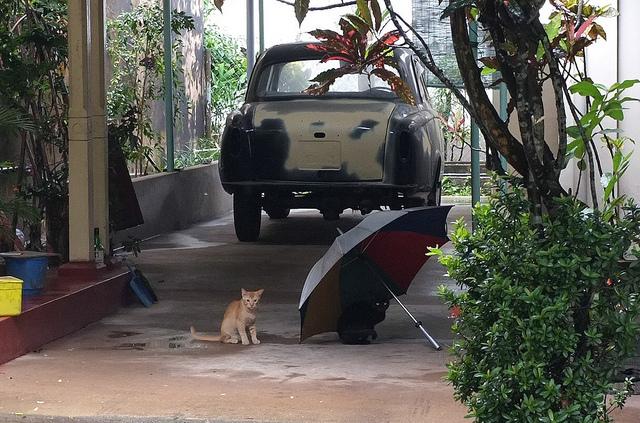Is the car in the back new?
Quick response, please. No. How many cats are shown?
Concise answer only. 1. Is there an umbrella?
Be succinct. Yes. 